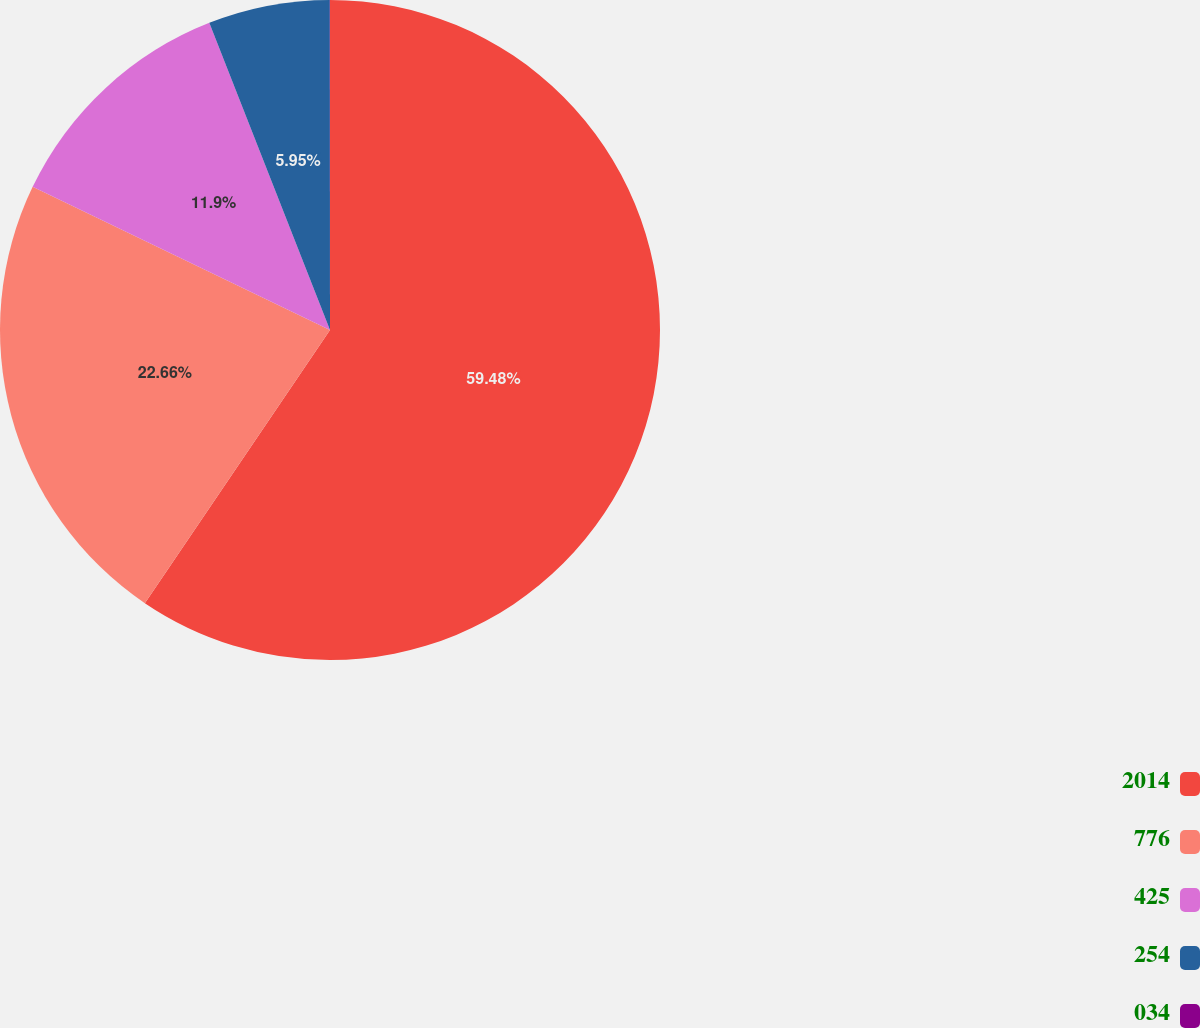<chart> <loc_0><loc_0><loc_500><loc_500><pie_chart><fcel>2014<fcel>776<fcel>425<fcel>254<fcel>034<nl><fcel>59.48%<fcel>22.66%<fcel>11.9%<fcel>5.95%<fcel>0.01%<nl></chart> 